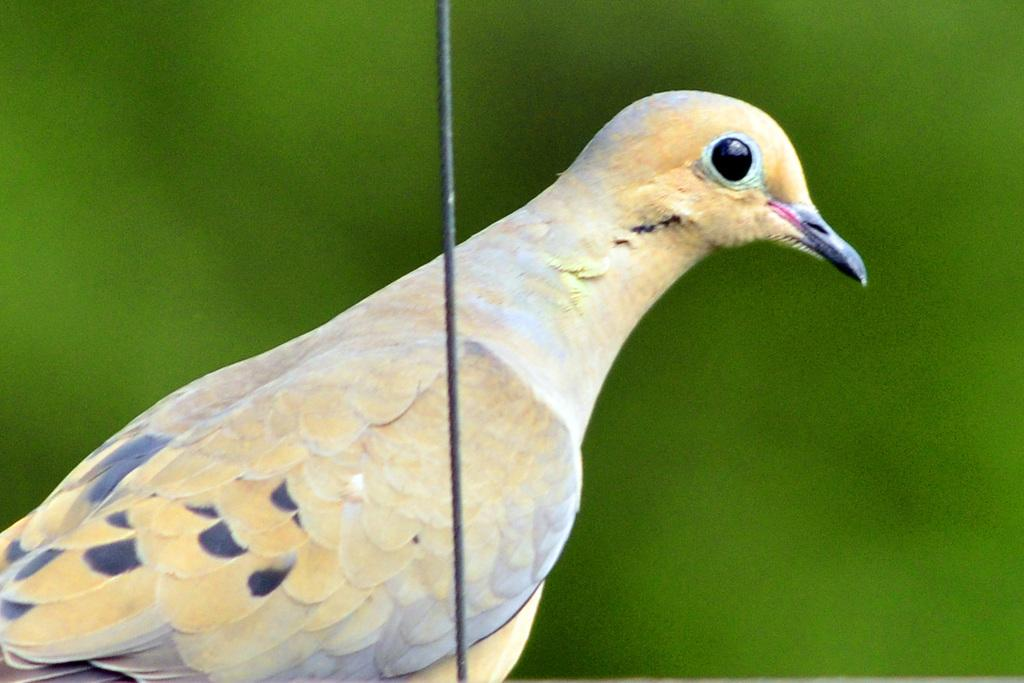What type of animal is in the image? There is a bird in the image. Can you describe the bird's coloring? The bird has cream, white, and black coloring. What else can be seen in the image besides the bird? There is a black color wire in the image. What is the color of the background in the image? The background of the image is green. What type of treatment does the bird receive for its hobbies in the image? There is no indication in the image that the bird is receiving any treatment or engaging in hobbies. 